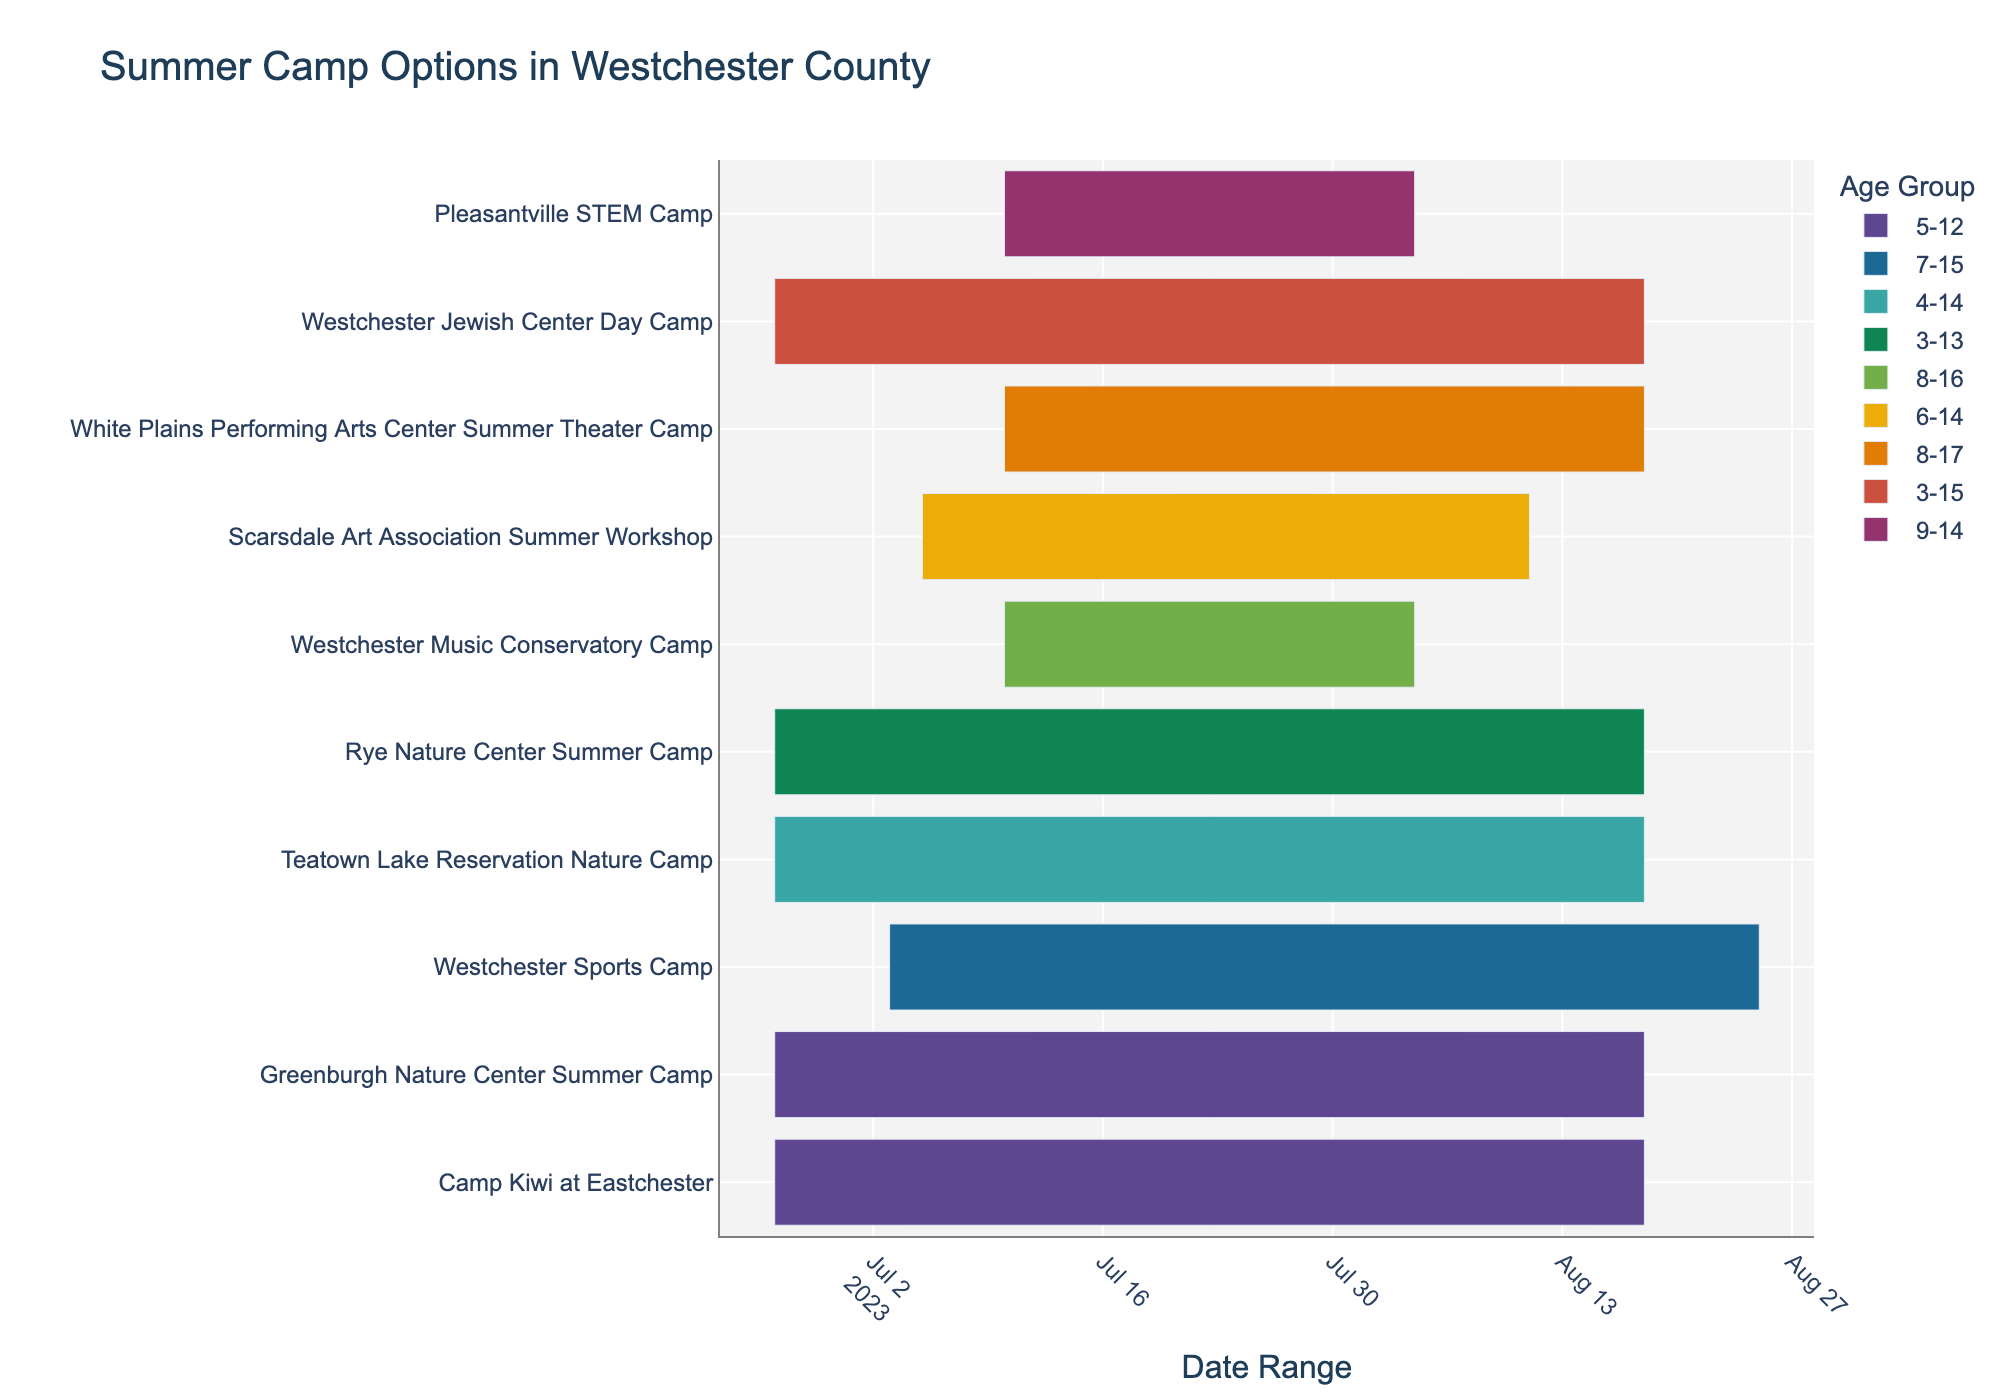Which summer camp runs the longest? To determine the longest-running summer camp, check the start and end dates of all the camps. Compare the duration of each camp by subtracting the start date from the end date.
Answer: Westchester Sports Camp Which age group is catered to by the highest number of camps? Identify the age groups for each camp by examining the color codes on the chart. Count how many camps are catering to each age group.
Answer: 5-12 Which activities overlap for the 8-17 age group? Identify the camps that serve the 8-17 age group by their color. Check the date ranges to see which camps have overlapping periods.
Answer: Westchester Music Conservatory Camp and White Plains Performing Arts Center Summer Theater Camp How many camps start on June 26, 2023? Look at the start dates on the Gantt chart to find which camps begin on June 26, 2023. Count the total number of these camps.
Answer: 5 If a child is interested in attending camps back-to-back, which two camps have consecutive dates for the age group 9-14? Find the camps that serve the 9-14 age group. Check their end and start dates to identify if any of the camps end and another starts immediately the next day.
Answer: Pleasantville STEM Camp followed by Scarsdale Art Association Summer Workshop Which camp is exclusively for children aged 4-14? Investigate the age groups for each camp and look for the camp that specifically lists 4-14 as its range.
Answer: Teatown Lake Reservation Nature Camp Do any camps have identical date ranges? Compare the start and end dates of each camp to see if any two camps have the exact same date ranges.
Answer: Yes, Camp Kiwi at Eastchester and Greenburgh Nature Center Summer Camp What is the shortest summer camp duration? Examine the start and end dates of each camp and calculate the duration by subtracting the start date from the end date. Identify the shortest duration.
Answer: Pleasantville STEM Camp and Westchester Music Conservatory Camp (both 4 weeks) Which camp includes the oldest age group of up to 17 years? Look at the age ranges for each camp and identify which camp allows children up to 17 years old.
Answer: White Plains Performing Arts Center Summer Theater Camp 